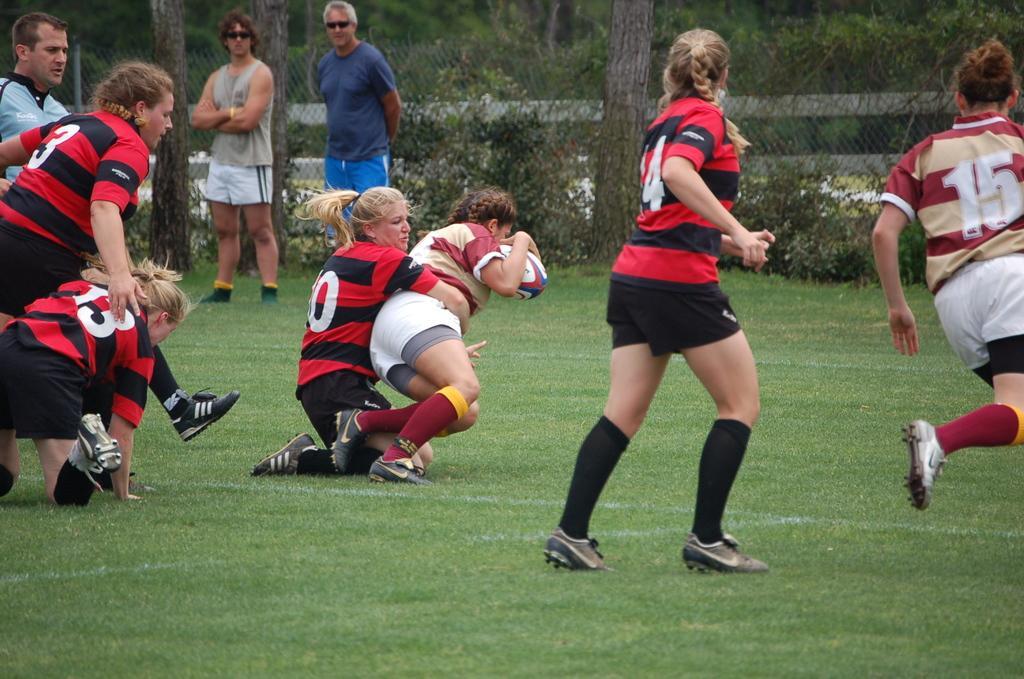Please provide a concise description of this image. As we can see in the image there are group of people, grass, plants, fence and trees. 